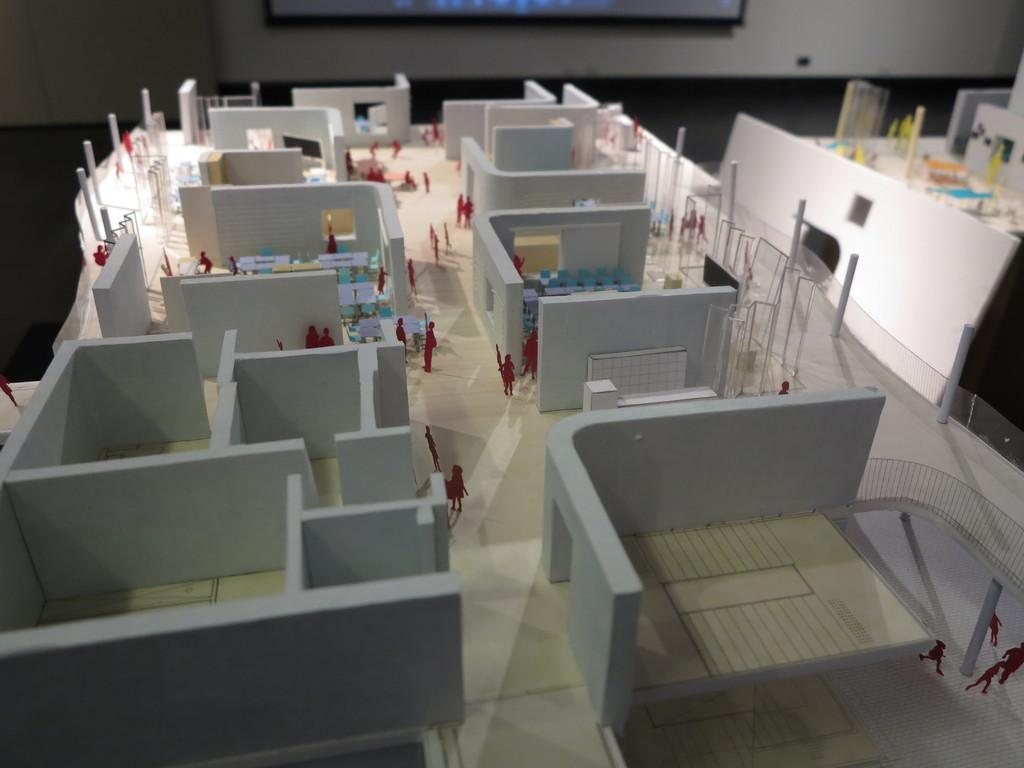What type of structure is depicted in the image? The image contains a miniature of a building. What can be seen in the background of the image? There is a wall in the background of the image. What is the surface on which the miniature building is placed? There is a floor at the bottom of the image. What type of ear can be seen in the image? There is no ear present in the image; it features a miniature building, a wall, and a floor. What type of destruction is occurring in the image? There is no destruction present in the image; it is a static representation of a miniature building, a wall, and a floor. 